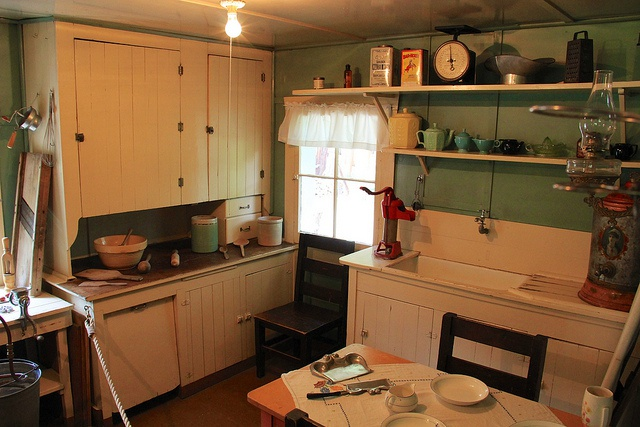Describe the objects in this image and their specific colors. I can see dining table in gray, tan, and brown tones, chair in gray, black, and maroon tones, chair in gray, black, and brown tones, sink in gray, tan, brown, and maroon tones, and bowl in gray, tan, and brown tones in this image. 